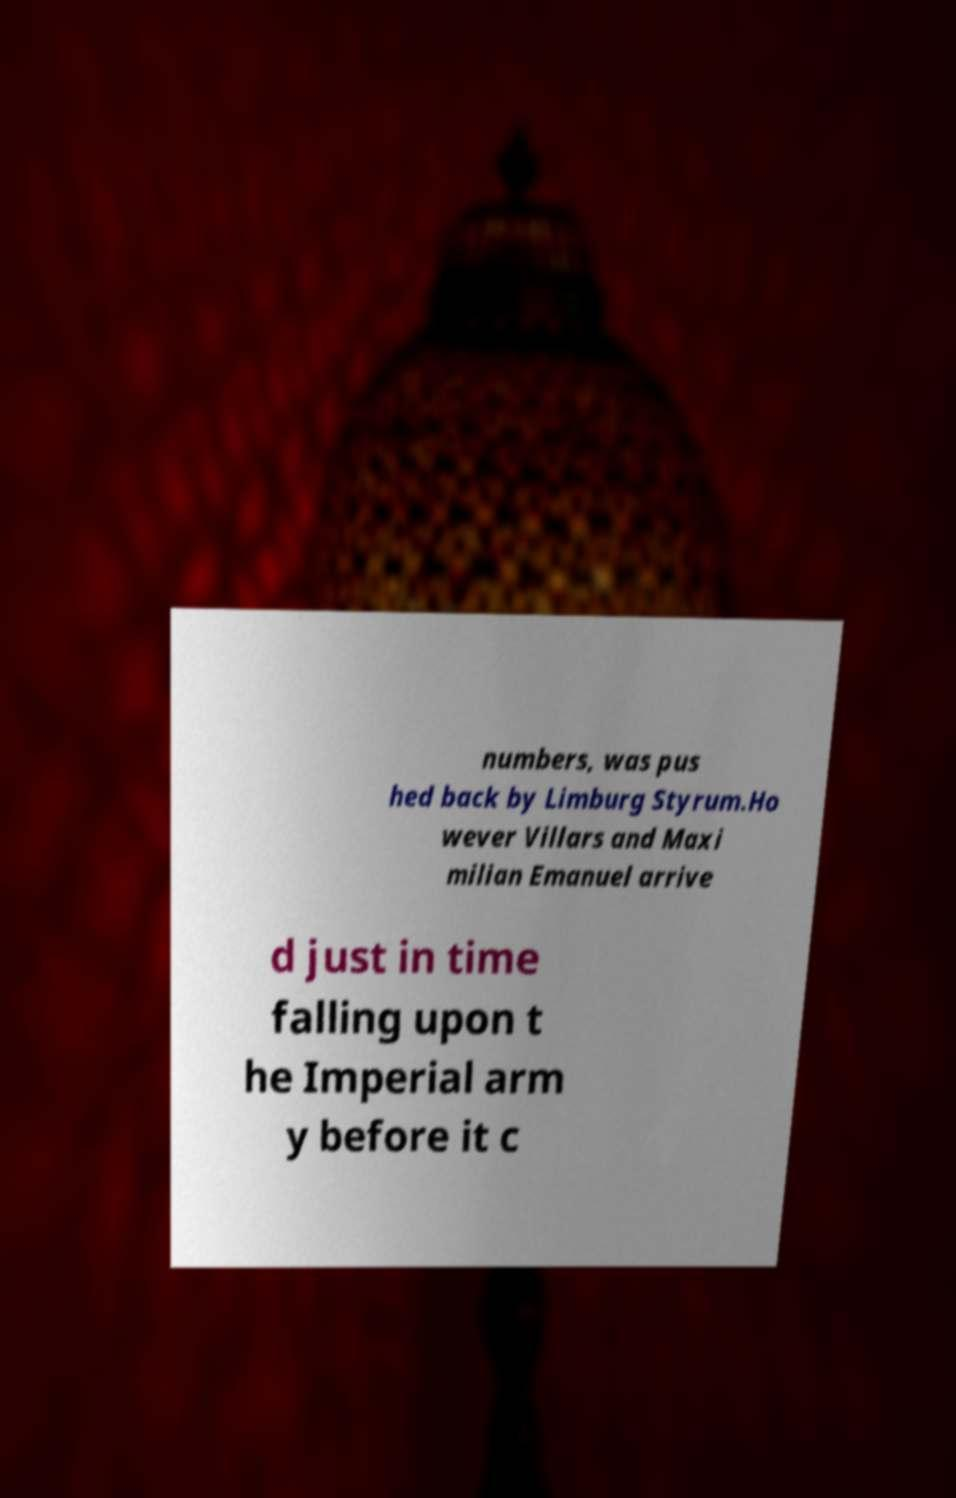Could you extract and type out the text from this image? numbers, was pus hed back by Limburg Styrum.Ho wever Villars and Maxi milian Emanuel arrive d just in time falling upon t he Imperial arm y before it c 